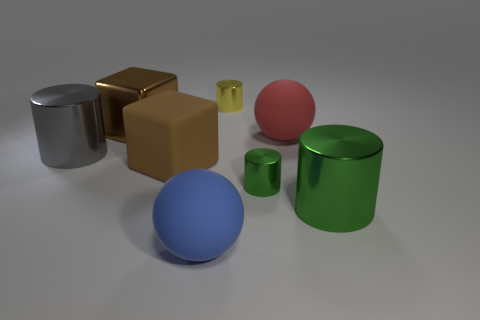Subtract all green cylinders. Subtract all green cubes. How many cylinders are left? 2 Add 1 large red things. How many objects exist? 9 Subtract all blocks. How many objects are left? 6 Subtract 1 blue balls. How many objects are left? 7 Subtract all big brown metal objects. Subtract all tiny green objects. How many objects are left? 6 Add 7 red rubber objects. How many red rubber objects are left? 8 Add 1 small red rubber spheres. How many small red rubber spheres exist? 1 